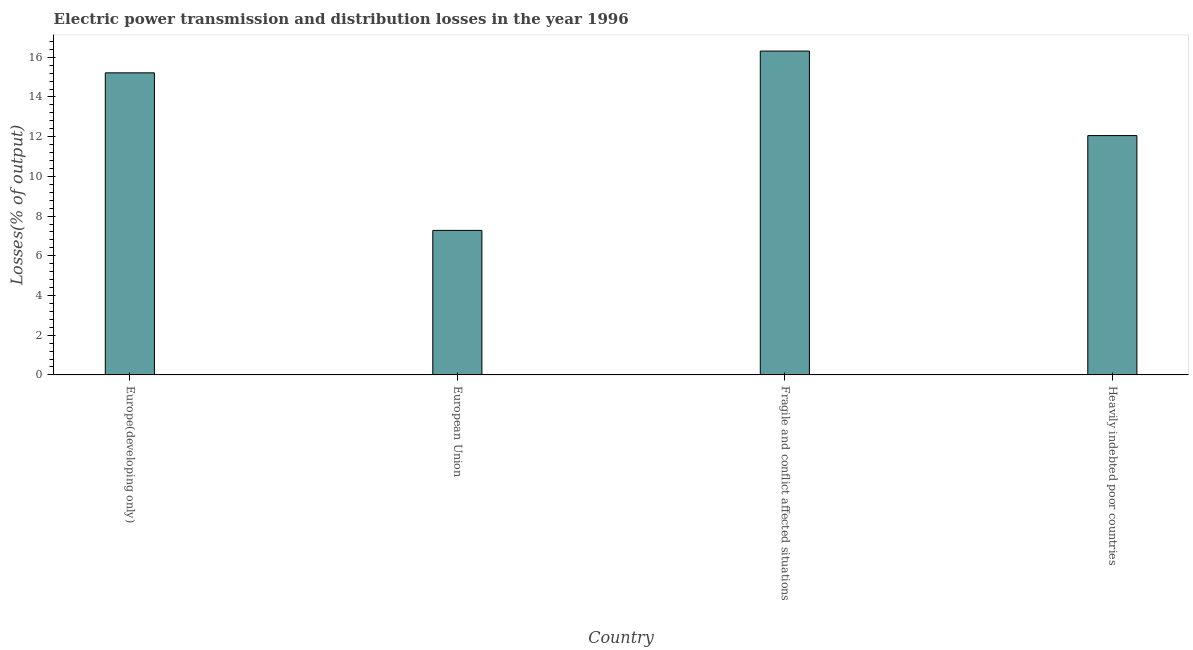Does the graph contain any zero values?
Give a very brief answer. No. What is the title of the graph?
Make the answer very short. Electric power transmission and distribution losses in the year 1996. What is the label or title of the X-axis?
Give a very brief answer. Country. What is the label or title of the Y-axis?
Keep it short and to the point. Losses(% of output). What is the electric power transmission and distribution losses in European Union?
Your answer should be very brief. 7.28. Across all countries, what is the maximum electric power transmission and distribution losses?
Ensure brevity in your answer.  16.31. Across all countries, what is the minimum electric power transmission and distribution losses?
Give a very brief answer. 7.28. In which country was the electric power transmission and distribution losses maximum?
Give a very brief answer. Fragile and conflict affected situations. What is the sum of the electric power transmission and distribution losses?
Make the answer very short. 50.86. What is the difference between the electric power transmission and distribution losses in Europe(developing only) and Fragile and conflict affected situations?
Ensure brevity in your answer.  -1.1. What is the average electric power transmission and distribution losses per country?
Keep it short and to the point. 12.72. What is the median electric power transmission and distribution losses?
Offer a very short reply. 13.64. What is the ratio of the electric power transmission and distribution losses in Europe(developing only) to that in Heavily indebted poor countries?
Your response must be concise. 1.26. What is the difference between the highest and the second highest electric power transmission and distribution losses?
Your answer should be compact. 1.1. Is the sum of the electric power transmission and distribution losses in Fragile and conflict affected situations and Heavily indebted poor countries greater than the maximum electric power transmission and distribution losses across all countries?
Your answer should be compact. Yes. What is the difference between the highest and the lowest electric power transmission and distribution losses?
Your response must be concise. 9.03. In how many countries, is the electric power transmission and distribution losses greater than the average electric power transmission and distribution losses taken over all countries?
Your answer should be compact. 2. How many bars are there?
Your response must be concise. 4. Are all the bars in the graph horizontal?
Offer a very short reply. No. How many countries are there in the graph?
Provide a succinct answer. 4. Are the values on the major ticks of Y-axis written in scientific E-notation?
Offer a very short reply. No. What is the Losses(% of output) in Europe(developing only)?
Your answer should be compact. 15.22. What is the Losses(% of output) of European Union?
Offer a very short reply. 7.28. What is the Losses(% of output) in Fragile and conflict affected situations?
Offer a terse response. 16.31. What is the Losses(% of output) of Heavily indebted poor countries?
Provide a short and direct response. 12.05. What is the difference between the Losses(% of output) in Europe(developing only) and European Union?
Your response must be concise. 7.94. What is the difference between the Losses(% of output) in Europe(developing only) and Fragile and conflict affected situations?
Ensure brevity in your answer.  -1.1. What is the difference between the Losses(% of output) in Europe(developing only) and Heavily indebted poor countries?
Offer a very short reply. 3.16. What is the difference between the Losses(% of output) in European Union and Fragile and conflict affected situations?
Your response must be concise. -9.03. What is the difference between the Losses(% of output) in European Union and Heavily indebted poor countries?
Ensure brevity in your answer.  -4.77. What is the difference between the Losses(% of output) in Fragile and conflict affected situations and Heavily indebted poor countries?
Give a very brief answer. 4.26. What is the ratio of the Losses(% of output) in Europe(developing only) to that in European Union?
Offer a very short reply. 2.09. What is the ratio of the Losses(% of output) in Europe(developing only) to that in Fragile and conflict affected situations?
Your answer should be compact. 0.93. What is the ratio of the Losses(% of output) in Europe(developing only) to that in Heavily indebted poor countries?
Ensure brevity in your answer.  1.26. What is the ratio of the Losses(% of output) in European Union to that in Fragile and conflict affected situations?
Provide a short and direct response. 0.45. What is the ratio of the Losses(% of output) in European Union to that in Heavily indebted poor countries?
Ensure brevity in your answer.  0.6. What is the ratio of the Losses(% of output) in Fragile and conflict affected situations to that in Heavily indebted poor countries?
Ensure brevity in your answer.  1.35. 